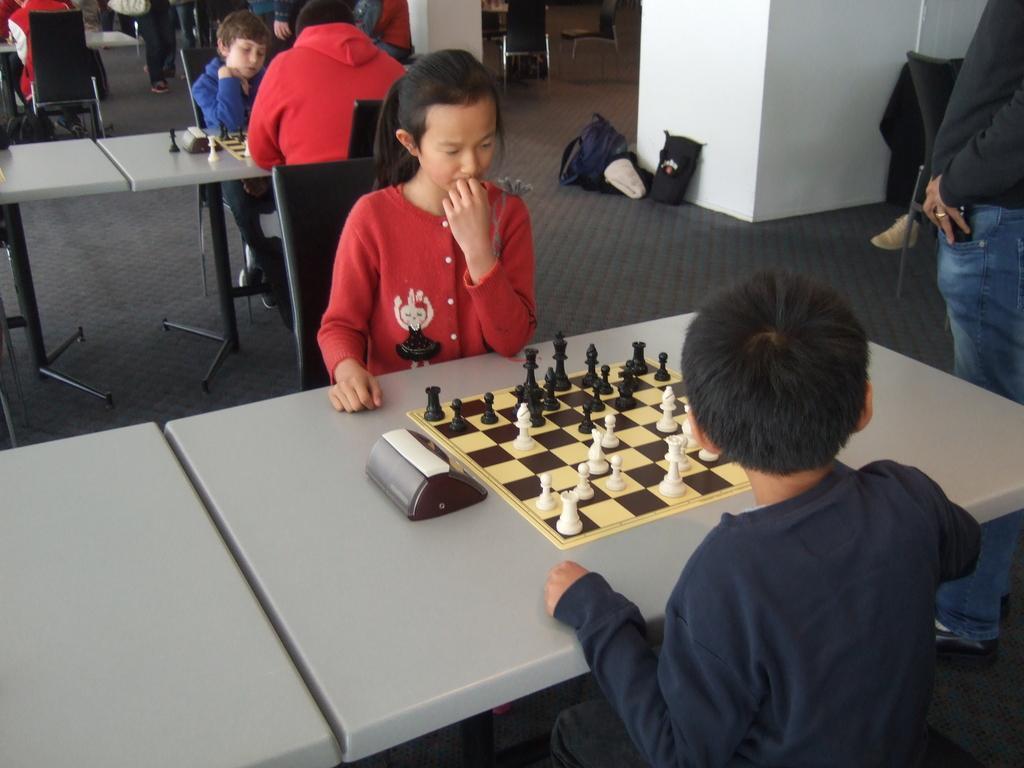In one or two sentences, can you explain what this image depicts? In the picture we can see some people are sitting on a chair near the tables on the table they are playing a chess. and we can see some bags near the wall. 